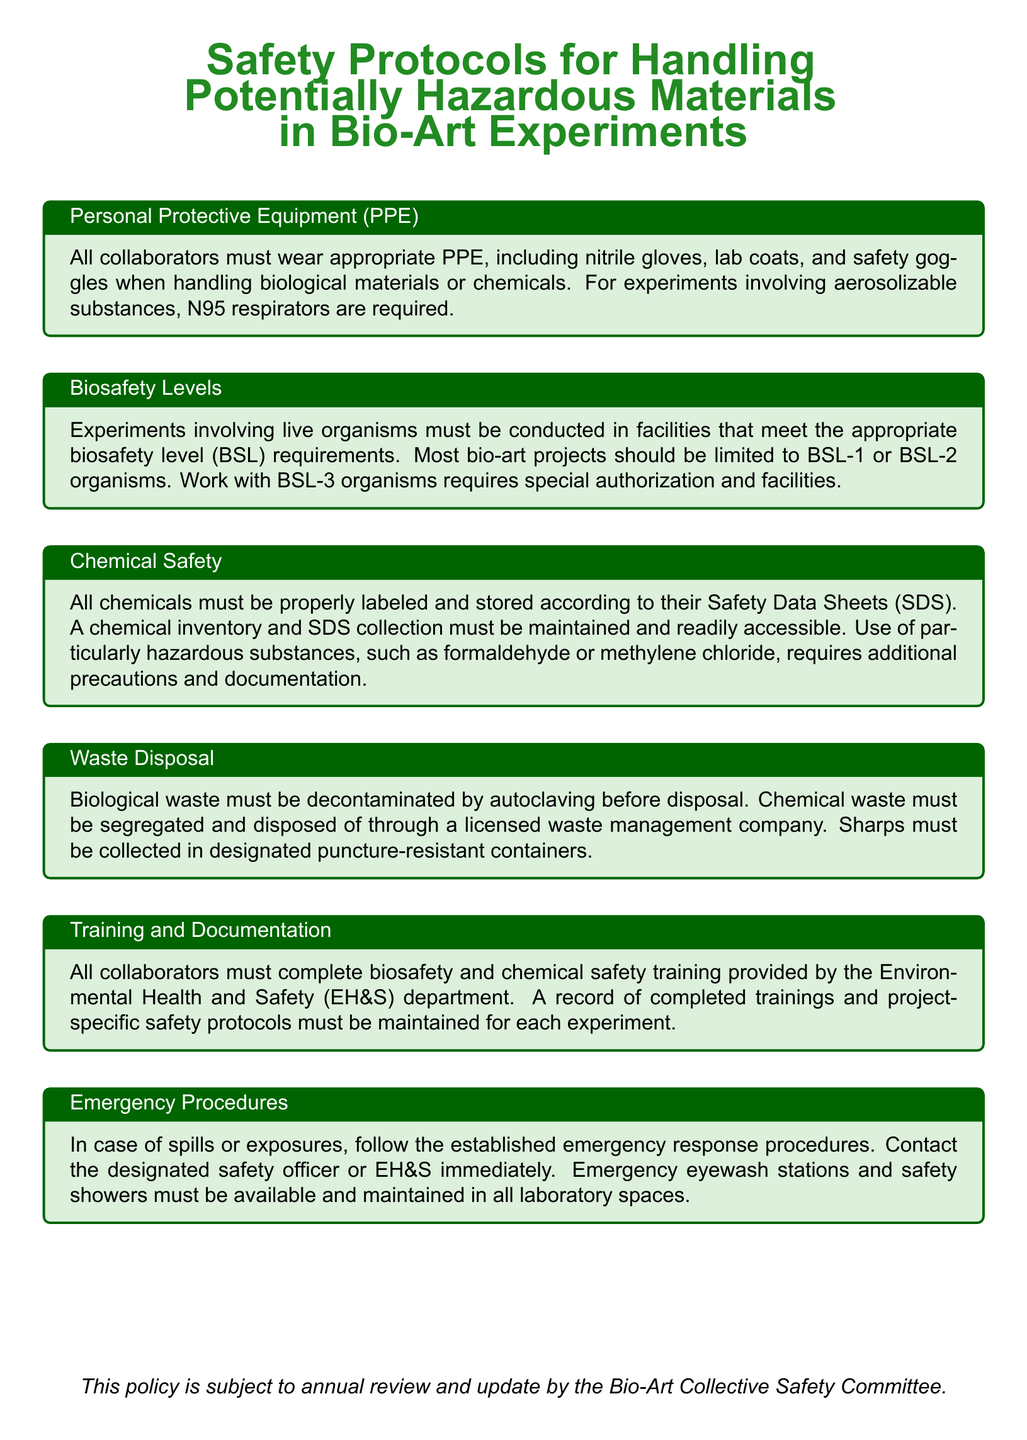What is the required PPE when handling biological materials? The document specifies that all collaborators must wear nitrile gloves, lab coats, and safety goggles.
Answer: nitrile gloves, lab coats, and safety goggles What biosafety level is generally appropriate for most bio-art projects? The document mentions that most bio-art projects should be limited to BSL-1 or BSL-2 organisms.
Answer: BSL-1 or BSL-2 What type of training must all collaborators complete? The document states that all collaborators must complete biosafety and chemical safety training provided by the EH&S department.
Answer: biosafety and chemical safety training What is the disposal method for biological waste? According to the document, biological waste must be decontaminated by autoclaving before disposal.
Answer: decontaminated by autoclaving What equipment must be available in all laboratory spaces? The document specifies that emergency eyewash stations and safety showers must be available and maintained.
Answer: emergency eyewash stations and safety showers What additional precautions are required for particularly hazardous substances? The document indicates that the use of particularly hazardous substances requires additional precautions and documentation.
Answer: additional precautions and documentation 